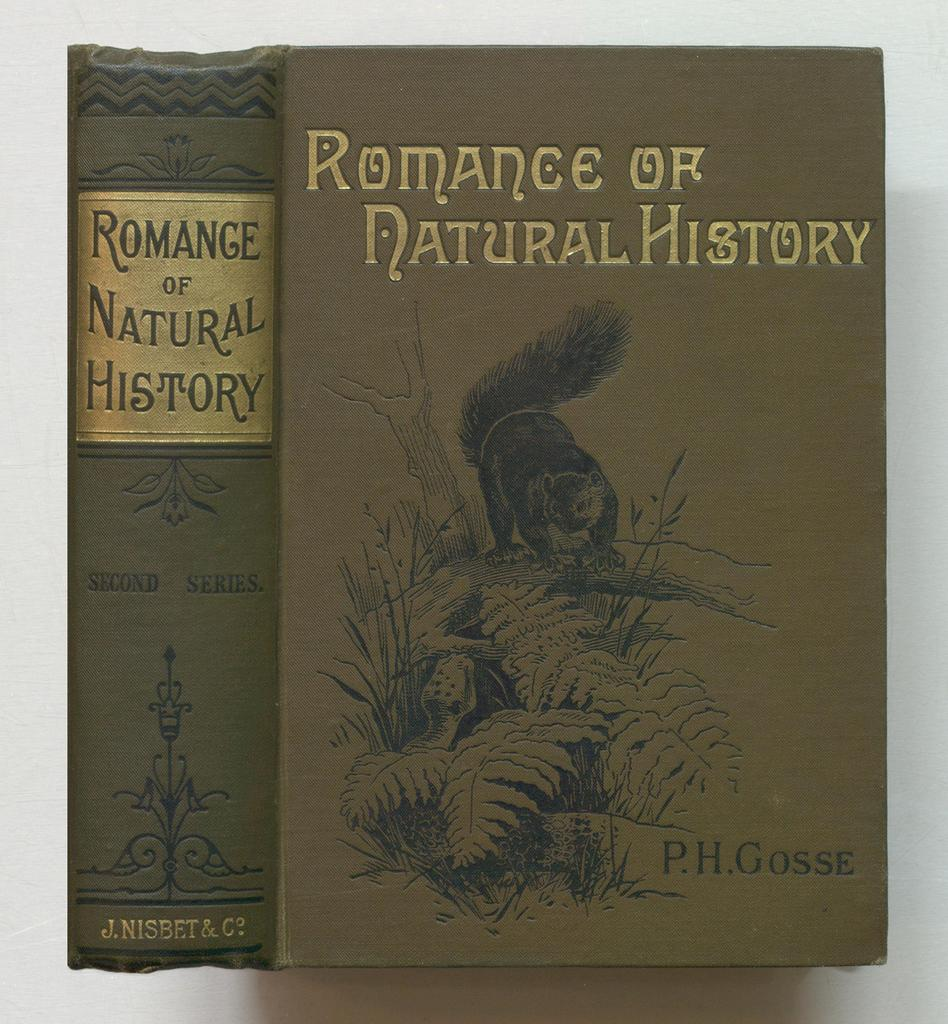<image>
Give a short and clear explanation of the subsequent image. A book written by P.H. Gosse concerns the Romance of Natural History. 